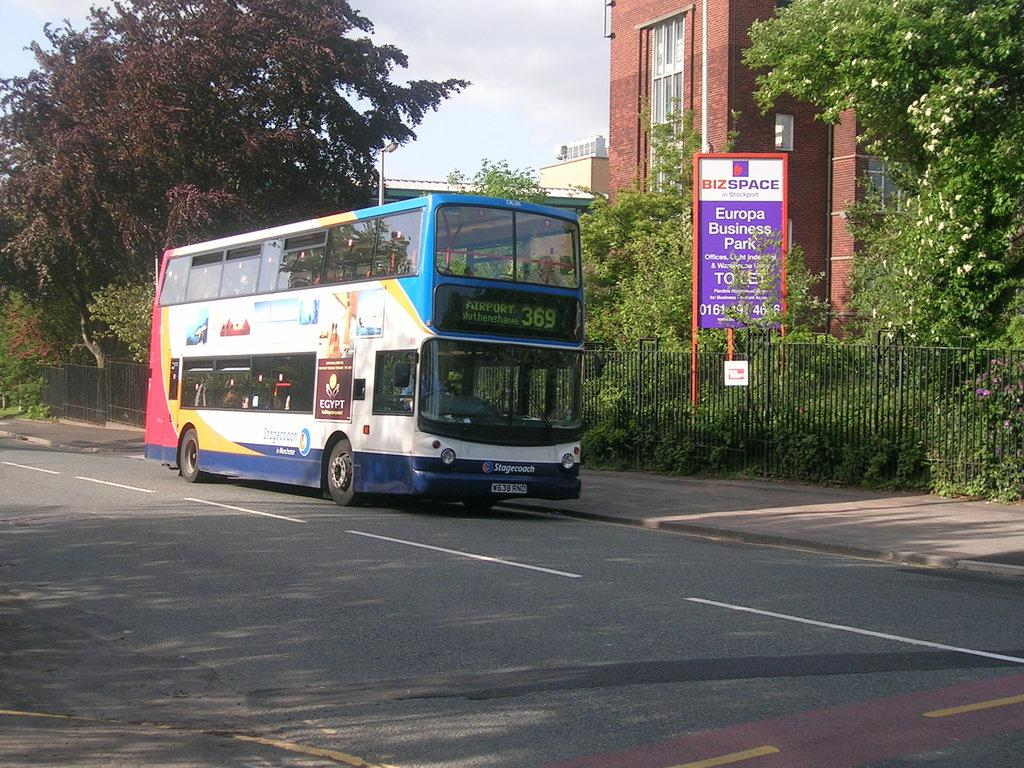What type of vehicle is on the road in the image? There is a bus on the road in the image. What is located behind the bus? There is a metal fence behind the bus. What can be seen on the side of the road in the image? There is a board in the image. What is visible in the background of the image? Trees, buildings, and the sky are visible in the background of the image. What type of soda is being advertised on the board in the image? There is no soda or advertisement present on the board in the image; it is a blank board. What is the value of the bus in the image? The value of the bus cannot be determined from the image alone, as it does not provide information about the bus's condition, age, or other factors that would affect its value. 